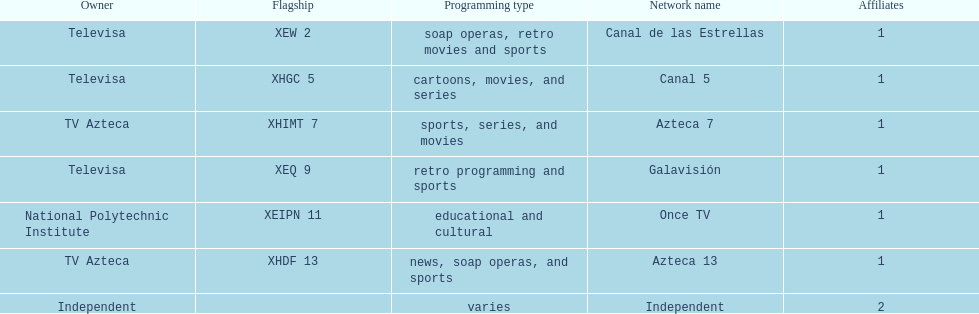Who is the only network owner listed in a consecutive order in the chart? Televisa. 